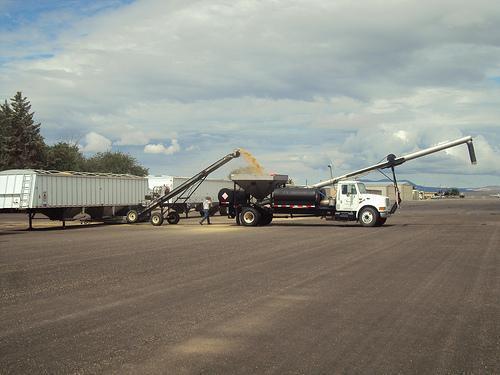How many people are there?
Give a very brief answer. 1. How many trailers are there?
Give a very brief answer. 2. How many people are visible?
Give a very brief answer. 1. 